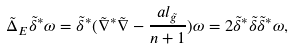Convert formula to latex. <formula><loc_0><loc_0><loc_500><loc_500>\tilde { \Delta } _ { E } \tilde { \delta } ^ { * } \omega = \tilde { \delta } ^ { * } ( \tilde { \nabla } ^ { * } \tilde { \nabla } - \frac { a l _ { \tilde { g } } } { n + 1 } ) \omega = 2 \tilde { \delta } ^ { * } \tilde { \delta } \tilde { \delta } ^ { * } \omega ,</formula> 